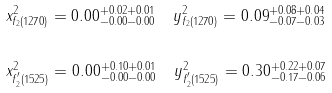Convert formula to latex. <formula><loc_0><loc_0><loc_500><loc_500>& x ^ { 2 } _ { f _ { 2 } ( 1 2 7 0 ) } = 0 . 0 0 ^ { + 0 . 0 2 + 0 . 0 1 } _ { - 0 . 0 0 - 0 . 0 0 } \quad y ^ { 2 } _ { f _ { 2 } ( 1 2 7 0 ) } = 0 . 0 9 ^ { + 0 . 0 8 + 0 . 0 4 } _ { - 0 . 0 7 - 0 . 0 3 } \\ \\ & x ^ { 2 } _ { f _ { 2 } ^ { ^ { \prime } } ( 1 5 2 5 ) } = 0 . 0 0 ^ { + 0 . 1 0 + 0 . 0 1 } _ { - 0 . 0 0 - 0 . 0 0 } \quad y ^ { 2 } _ { f _ { 2 } ^ { ^ { \prime } } ( 1 5 2 5 ) } = 0 . 3 0 ^ { + 0 . 2 2 + 0 . 0 7 } _ { - 0 . 1 7 - 0 . 0 6 } \\</formula> 